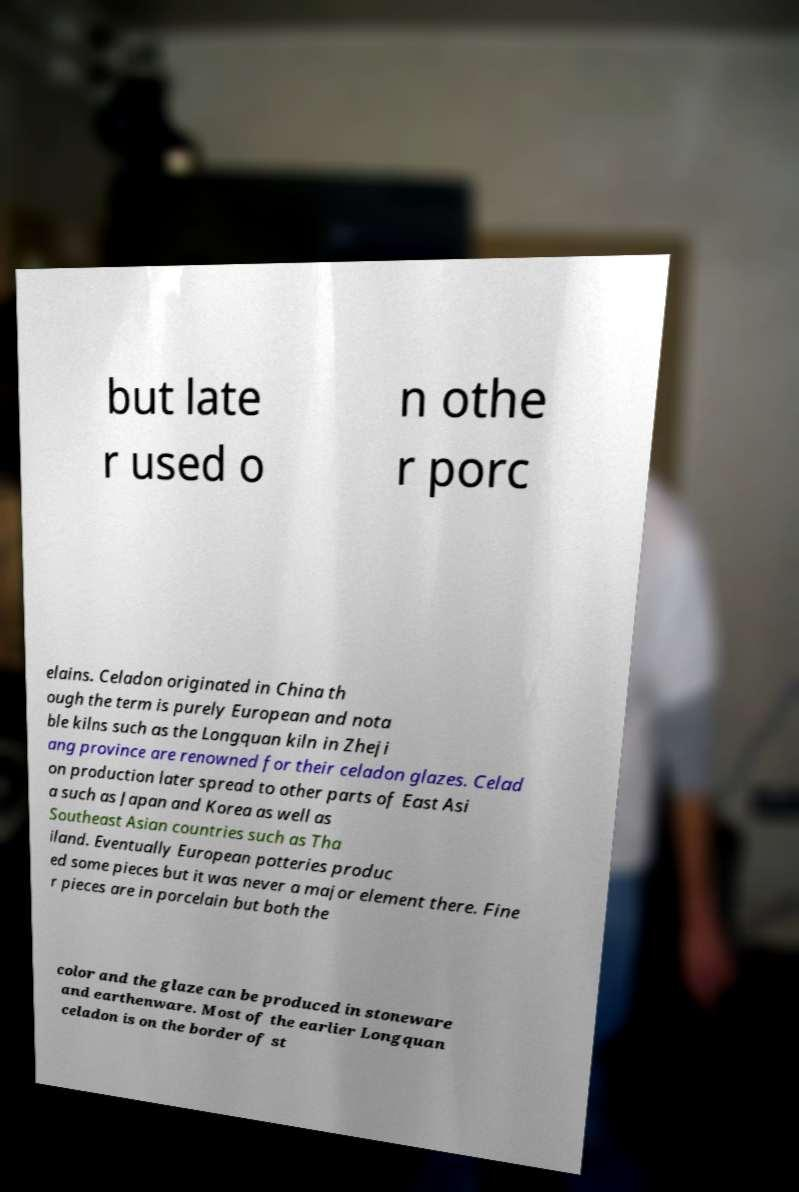Can you accurately transcribe the text from the provided image for me? but late r used o n othe r porc elains. Celadon originated in China th ough the term is purely European and nota ble kilns such as the Longquan kiln in Zheji ang province are renowned for their celadon glazes. Celad on production later spread to other parts of East Asi a such as Japan and Korea as well as Southeast Asian countries such as Tha iland. Eventually European potteries produc ed some pieces but it was never a major element there. Fine r pieces are in porcelain but both the color and the glaze can be produced in stoneware and earthenware. Most of the earlier Longquan celadon is on the border of st 